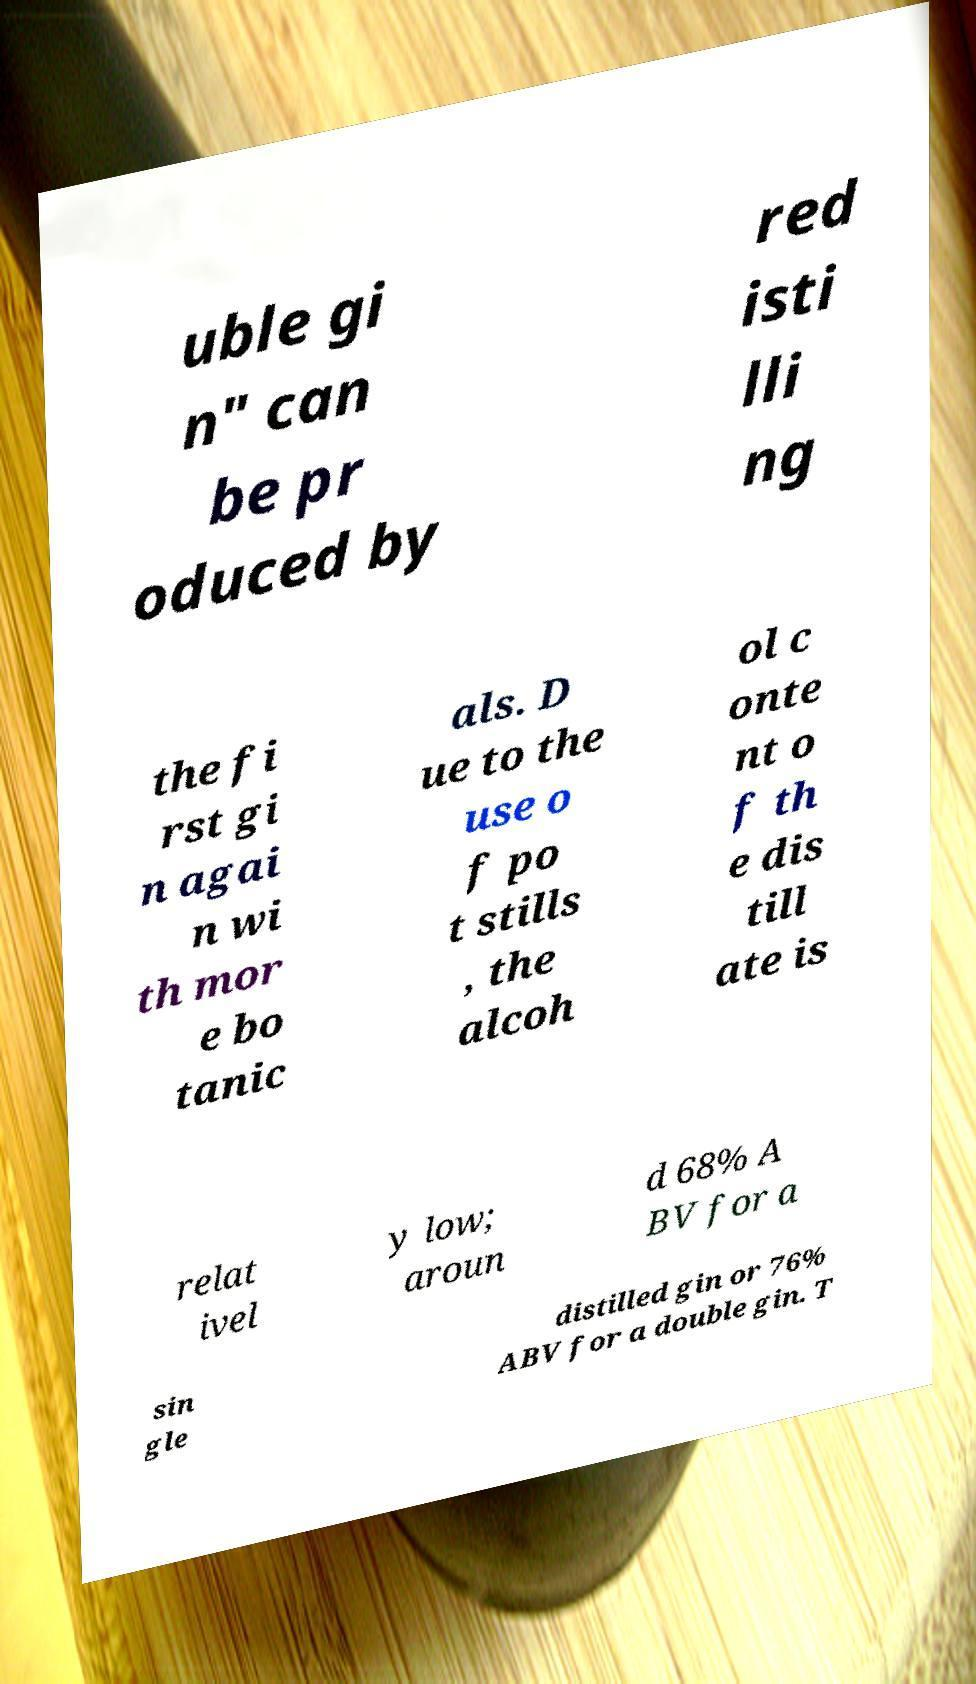Please read and relay the text visible in this image. What does it say? uble gi n" can be pr oduced by red isti lli ng the fi rst gi n agai n wi th mor e bo tanic als. D ue to the use o f po t stills , the alcoh ol c onte nt o f th e dis till ate is relat ivel y low; aroun d 68% A BV for a sin gle distilled gin or 76% ABV for a double gin. T 